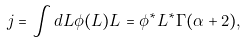Convert formula to latex. <formula><loc_0><loc_0><loc_500><loc_500>j = \int d L \phi ( L ) L = \phi ^ { * } L ^ { * } \Gamma ( \alpha + 2 ) ,</formula> 